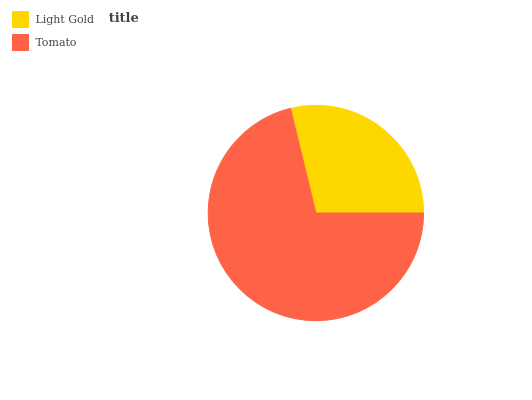Is Light Gold the minimum?
Answer yes or no. Yes. Is Tomato the maximum?
Answer yes or no. Yes. Is Tomato the minimum?
Answer yes or no. No. Is Tomato greater than Light Gold?
Answer yes or no. Yes. Is Light Gold less than Tomato?
Answer yes or no. Yes. Is Light Gold greater than Tomato?
Answer yes or no. No. Is Tomato less than Light Gold?
Answer yes or no. No. Is Tomato the high median?
Answer yes or no. Yes. Is Light Gold the low median?
Answer yes or no. Yes. Is Light Gold the high median?
Answer yes or no. No. Is Tomato the low median?
Answer yes or no. No. 